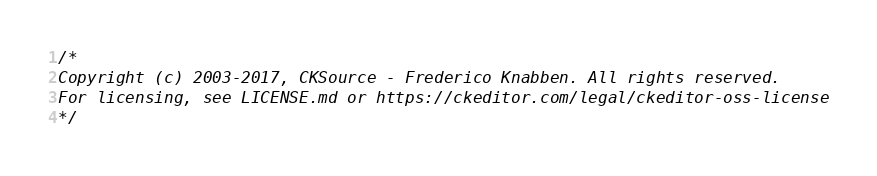<code> <loc_0><loc_0><loc_500><loc_500><_CSS_>/*
Copyright (c) 2003-2017, CKSource - Frederico Knabben. All rights reserved.
For licensing, see LICENSE.md or https://ckeditor.com/legal/ckeditor-oss-license
*/</code> 